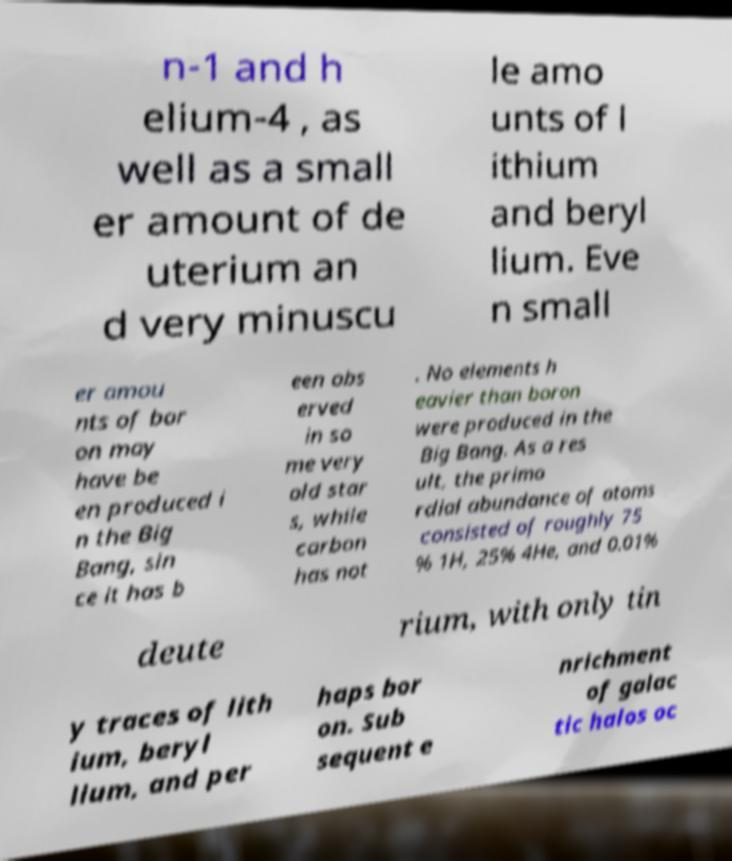Can you read and provide the text displayed in the image?This photo seems to have some interesting text. Can you extract and type it out for me? n-1 and h elium-4 , as well as a small er amount of de uterium an d very minuscu le amo unts of l ithium and beryl lium. Eve n small er amou nts of bor on may have be en produced i n the Big Bang, sin ce it has b een obs erved in so me very old star s, while carbon has not . No elements h eavier than boron were produced in the Big Bang. As a res ult, the primo rdial abundance of atoms consisted of roughly 75 % 1H, 25% 4He, and 0.01% deute rium, with only tin y traces of lith ium, beryl lium, and per haps bor on. Sub sequent e nrichment of galac tic halos oc 